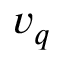<formula> <loc_0><loc_0><loc_500><loc_500>v _ { q }</formula> 